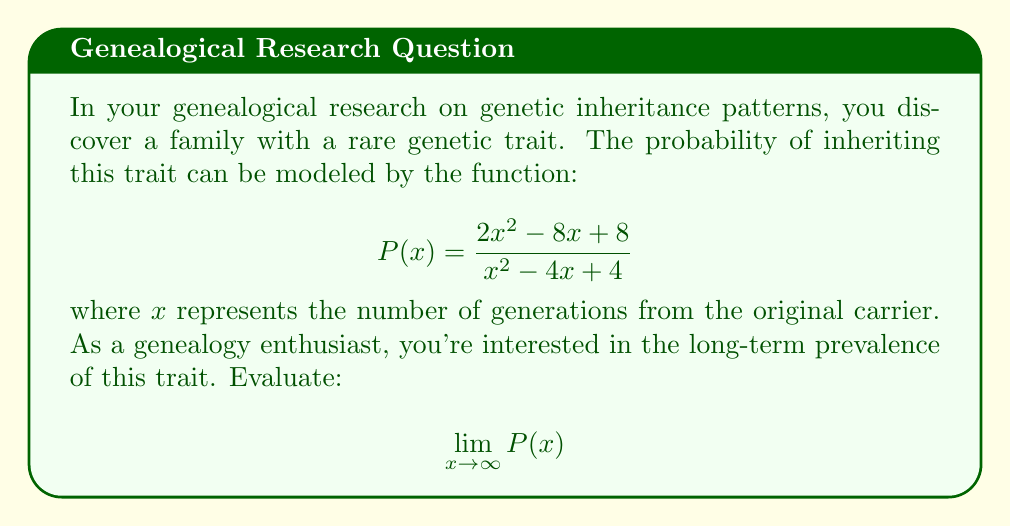What is the answer to this math problem? Let's approach this step-by-step:

1) To evaluate the limit as $x$ approaches infinity, we need to look at the highest degree terms in both the numerator and denominator.

2) In the numerator, the highest degree term is $2x^2$.
   In the denominator, the highest degree term is $x^2$.

3) We can factor out $x^2$ from both the numerator and denominator:

   $$\lim_{x \to \infty} \frac{2x^2 - 8x + 8}{x^2 - 4x + 4} = \lim_{x \to \infty} \frac{x^2(2 - \frac{8}{x} + \frac{8}{x^2})}{x^2(1 - \frac{4}{x} + \frac{4}{x^2})}$$

4) The $x^2$ terms cancel out:

   $$\lim_{x \to \infty} \frac{2 - \frac{8}{x} + \frac{8}{x^2}}{1 - \frac{4}{x} + \frac{4}{x^2}}$$

5) As $x$ approaches infinity, $\frac{1}{x}$ and $\frac{1}{x^2}$ approach 0:

   $$\lim_{x \to \infty} \frac{2 - 0 + 0}{1 - 0 + 0} = \frac{2}{1} = 2$$

6) Therefore, the long-term probability of inheriting this genetic trait approaches 2.
Answer: 2 